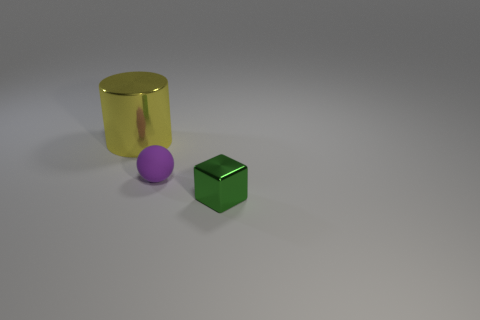How many things are large metal cylinders behind the tiny green metallic object or things in front of the metallic cylinder?
Your answer should be compact. 3. Is the number of large purple spheres less than the number of big yellow cylinders?
Offer a very short reply. Yes. Do the green shiny thing and the metal thing that is left of the small green thing have the same size?
Provide a short and direct response. No. What number of shiny objects are either balls or large red balls?
Make the answer very short. 0. Are there more metallic things than objects?
Make the answer very short. No. There is a small object that is left of the shiny object in front of the small rubber ball; what shape is it?
Ensure brevity in your answer.  Sphere. There is a object behind the small thing that is left of the green object; is there a tiny purple rubber ball in front of it?
Your answer should be very brief. Yes. What is the color of the block that is the same size as the purple matte object?
Keep it short and to the point. Green. What shape is the object that is behind the tiny cube and in front of the metal cylinder?
Your answer should be compact. Sphere. There is a metal object left of the metal object that is in front of the big cylinder; what size is it?
Your response must be concise. Large. 